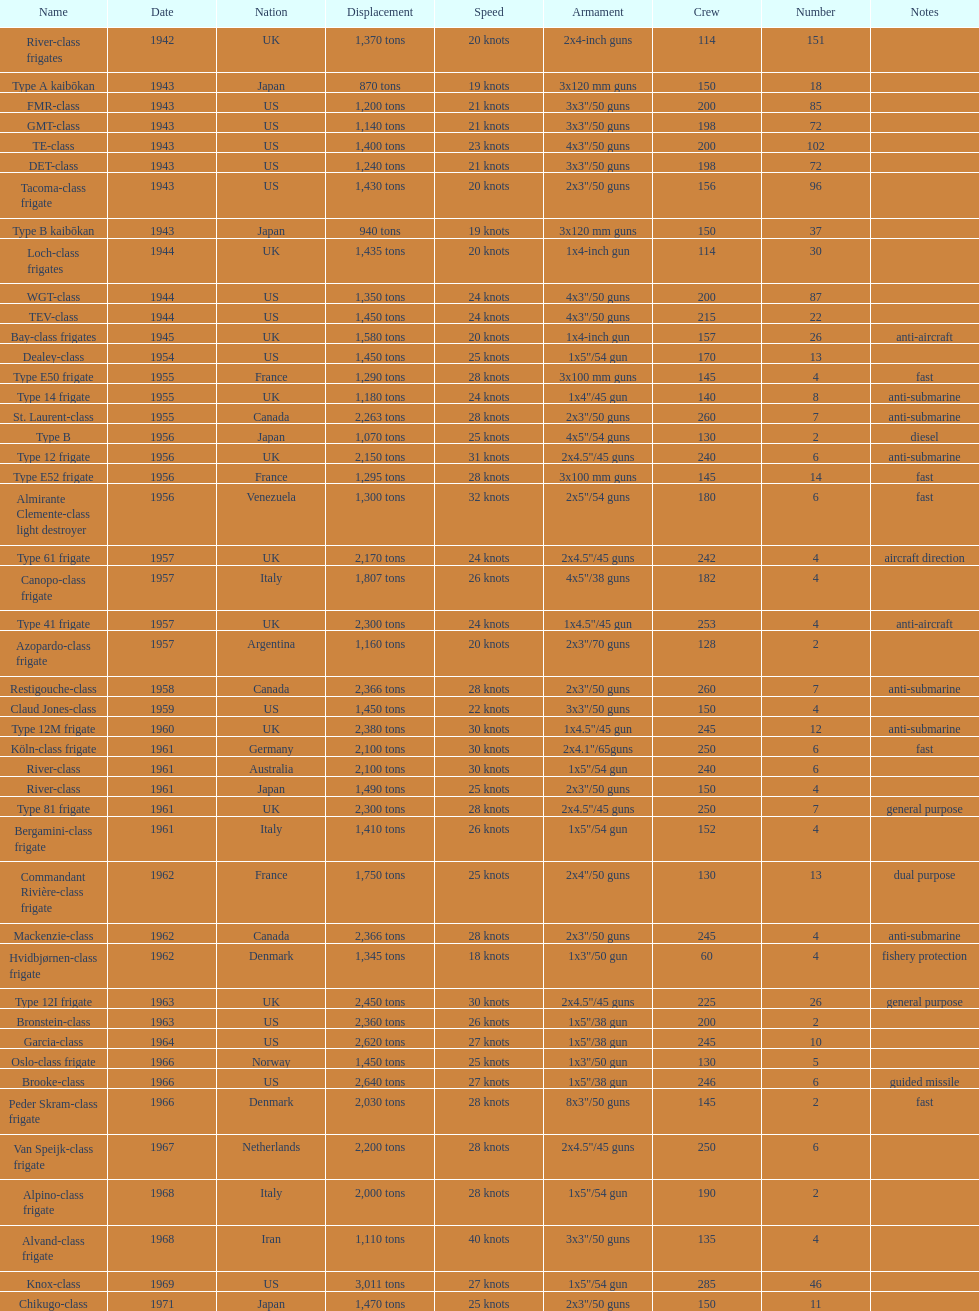In 1968 italy used alpino-class frigate. what was its top speed? 28 knots. 